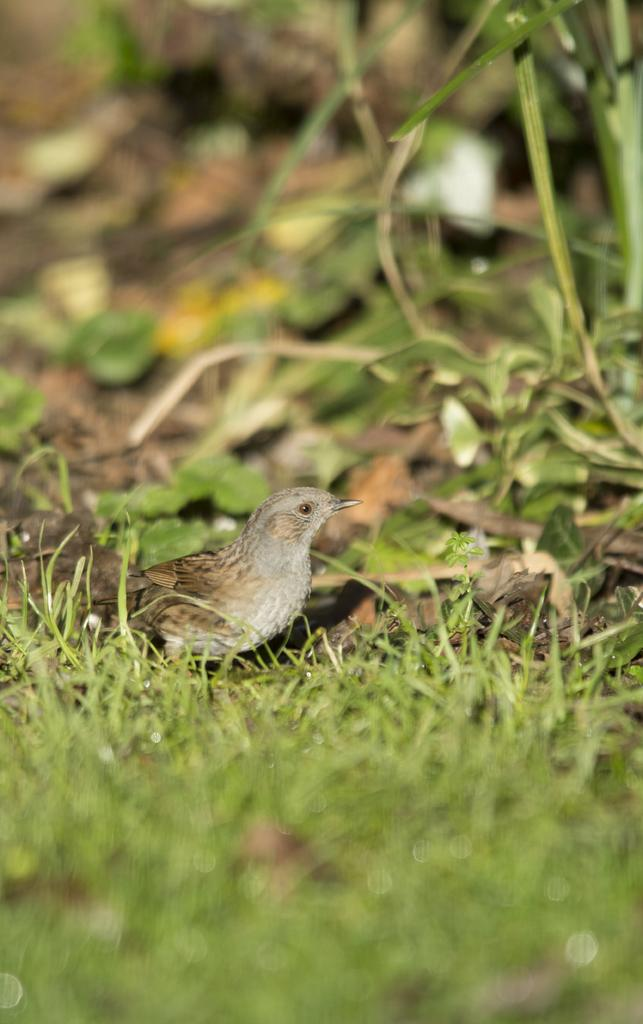What type of terrain is visible in the image? There is grass on the ground in the image. What is the main subject in the center of the image? There is a bird in the center of the image. What can be seen in the background of the image? There are leaves visible in the background of the image. What type of actor is performing in the image? There is no actor present in the image; it features a bird and grass. What type of mint can be seen growing in the image? There is no mint present in the image; it features a bird, grass, and leaves. 